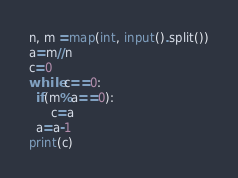<code> <loc_0><loc_0><loc_500><loc_500><_Python_>n, m =map(int, input().split())
a=m//n
c=0
while c==0:
  if(m%a==0):
      c=a
  a=a-1
print(c)</code> 